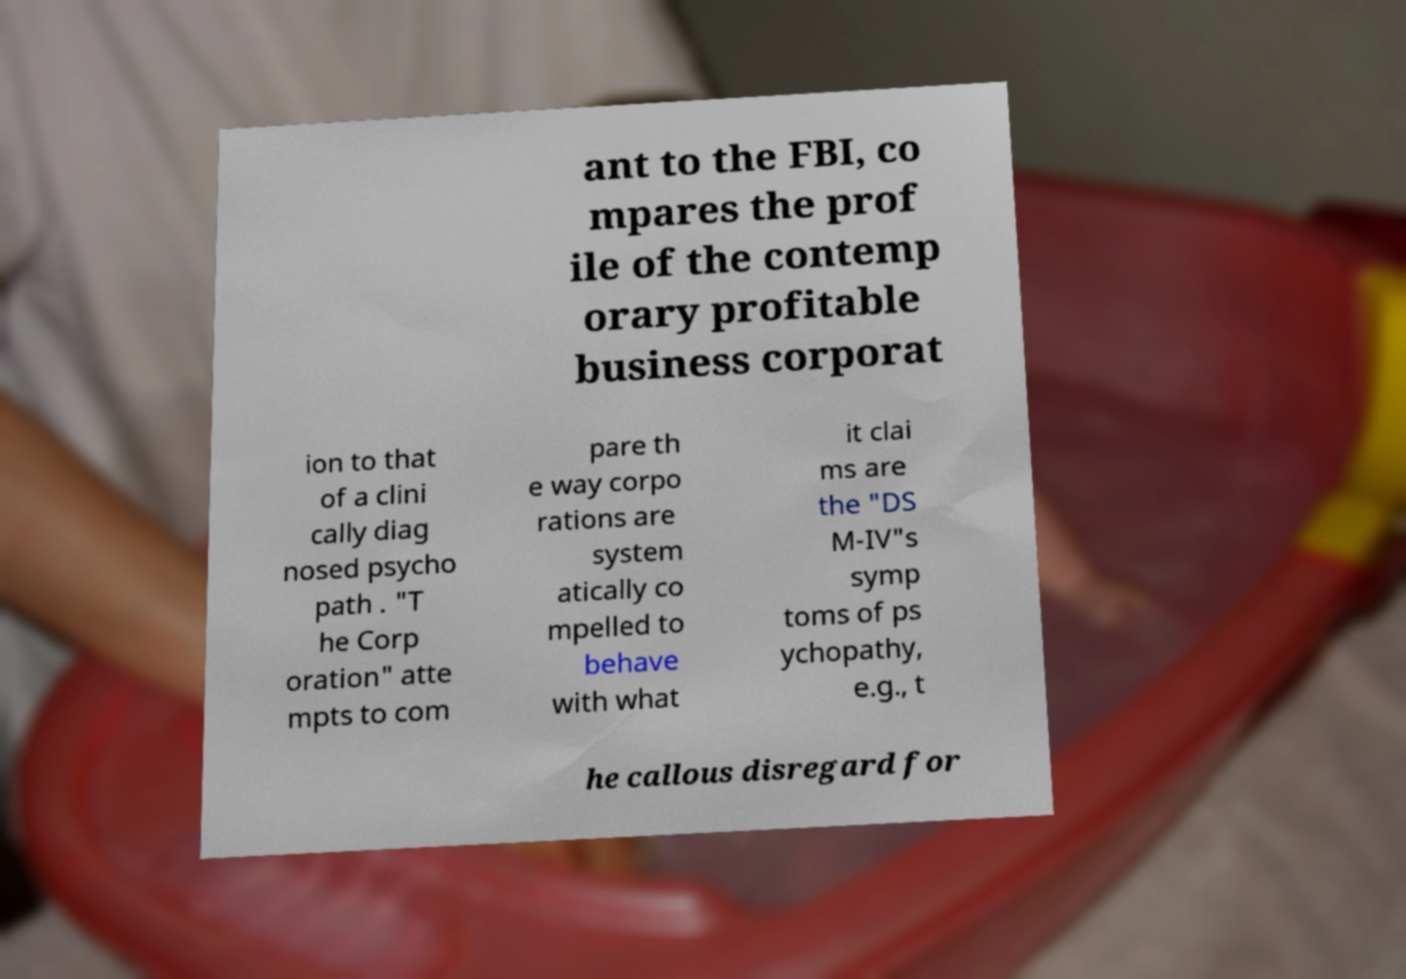Can you read and provide the text displayed in the image?This photo seems to have some interesting text. Can you extract and type it out for me? ant to the FBI, co mpares the prof ile of the contemp orary profitable business corporat ion to that of a clini cally diag nosed psycho path . "T he Corp oration" atte mpts to com pare th e way corpo rations are system atically co mpelled to behave with what it clai ms are the "DS M-IV"s symp toms of ps ychopathy, e.g., t he callous disregard for 